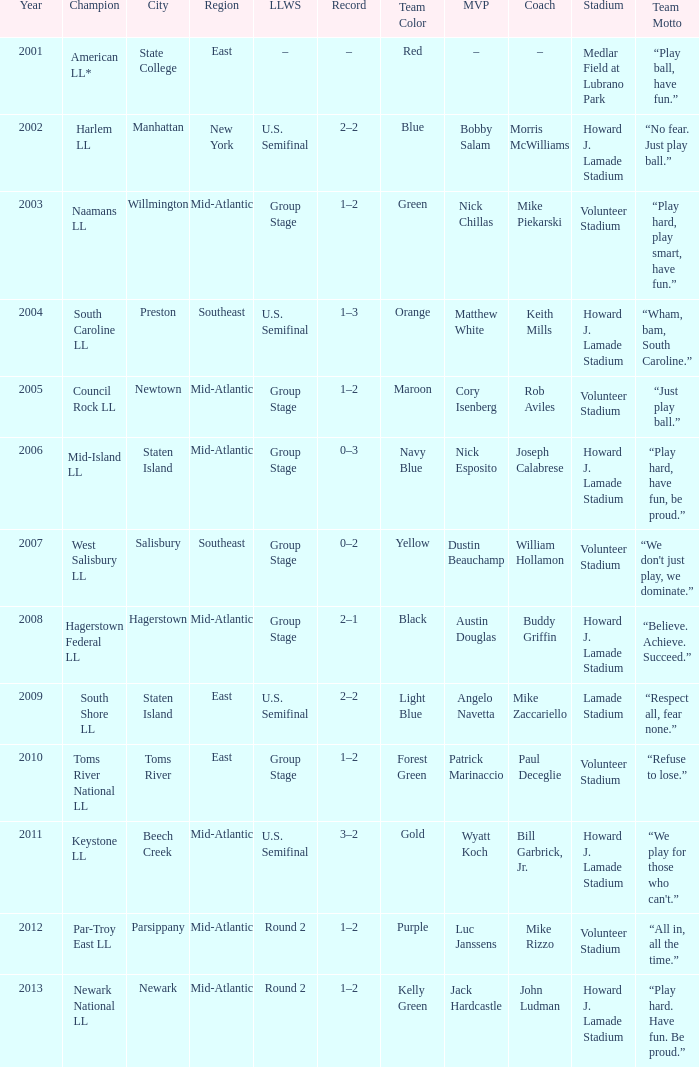In which little league world series was parsippany the location? Round 2. Give me the full table as a dictionary. {'header': ['Year', 'Champion', 'City', 'Region', 'LLWS', 'Record', 'Team Color', 'MVP', 'Coach', 'Stadium', 'Team Motto'], 'rows': [['2001', 'American LL*', 'State College', 'East', '–', '–', 'Red', '–', '–', 'Medlar Field at Lubrano Park', '“Play ball, have fun.”'], ['2002', 'Harlem LL', 'Manhattan', 'New York', 'U.S. Semifinal', '2–2', 'Blue', 'Bobby Salam', 'Morris McWilliams', 'Howard J. Lamade Stadium', '“No fear. Just play ball.”'], ['2003', 'Naamans LL', 'Willmington', 'Mid-Atlantic', 'Group Stage', '1–2', 'Green', 'Nick Chillas', 'Mike Piekarski', 'Volunteer Stadium', '“Play hard, play smart, have fun.”'], ['2004', 'South Caroline LL', 'Preston', 'Southeast', 'U.S. Semifinal', '1–3', 'Orange', 'Matthew White', 'Keith Mills', 'Howard J. Lamade Stadium', '“Wham, bam, South Caroline.”'], ['2005', 'Council Rock LL', 'Newtown', 'Mid-Atlantic', 'Group Stage', '1–2', 'Maroon', 'Cory Isenberg', 'Rob Aviles', 'Volunteer Stadium', '“Just play ball.”'], ['2006', 'Mid-Island LL', 'Staten Island', 'Mid-Atlantic', 'Group Stage', '0–3', 'Navy Blue', 'Nick Esposito', 'Joseph Calabrese', 'Howard J. Lamade Stadium', '“Play hard, have fun, be proud.”'], ['2007', 'West Salisbury LL', 'Salisbury', 'Southeast', 'Group Stage', '0–2', 'Yellow', 'Dustin Beauchamp', 'William Hollamon', 'Volunteer Stadium', "“We don't just play, we dominate.”"], ['2008', 'Hagerstown Federal LL', 'Hagerstown', 'Mid-Atlantic', 'Group Stage', '2–1', 'Black', 'Austin Douglas', 'Buddy Griffin', 'Howard J. Lamade Stadium', '“Believe. Achieve. Succeed.”'], ['2009', 'South Shore LL', 'Staten Island', 'East', 'U.S. Semifinal', '2–2', 'Light Blue', 'Angelo Navetta', 'Mike Zaccariello', 'Lamade Stadium', '“Respect all, fear none.”'], ['2010', 'Toms River National LL', 'Toms River', 'East', 'Group Stage', '1–2', 'Forest Green', 'Patrick Marinaccio', 'Paul Deceglie', 'Volunteer Stadium', '“Refuse to lose.”'], ['2011', 'Keystone LL', 'Beech Creek', 'Mid-Atlantic', 'U.S. Semifinal', '3–2', 'Gold', 'Wyatt Koch', 'Bill Garbrick, Jr.', 'Howard J. Lamade Stadium', "“We play for those who can't.”"], ['2012', 'Par-Troy East LL', 'Parsippany', 'Mid-Atlantic', 'Round 2', '1–2', 'Purple', 'Luc Janssens', 'Mike Rizzo', 'Volunteer Stadium', '“All in, all the time.”'], ['2013', 'Newark National LL', 'Newark', 'Mid-Atlantic', 'Round 2', '1–2', 'Kelly Green', 'Jack Hardcastle', 'John Ludman', 'Howard J. Lamade Stadium', '“Play hard. Have fun. Be proud.”']]} 